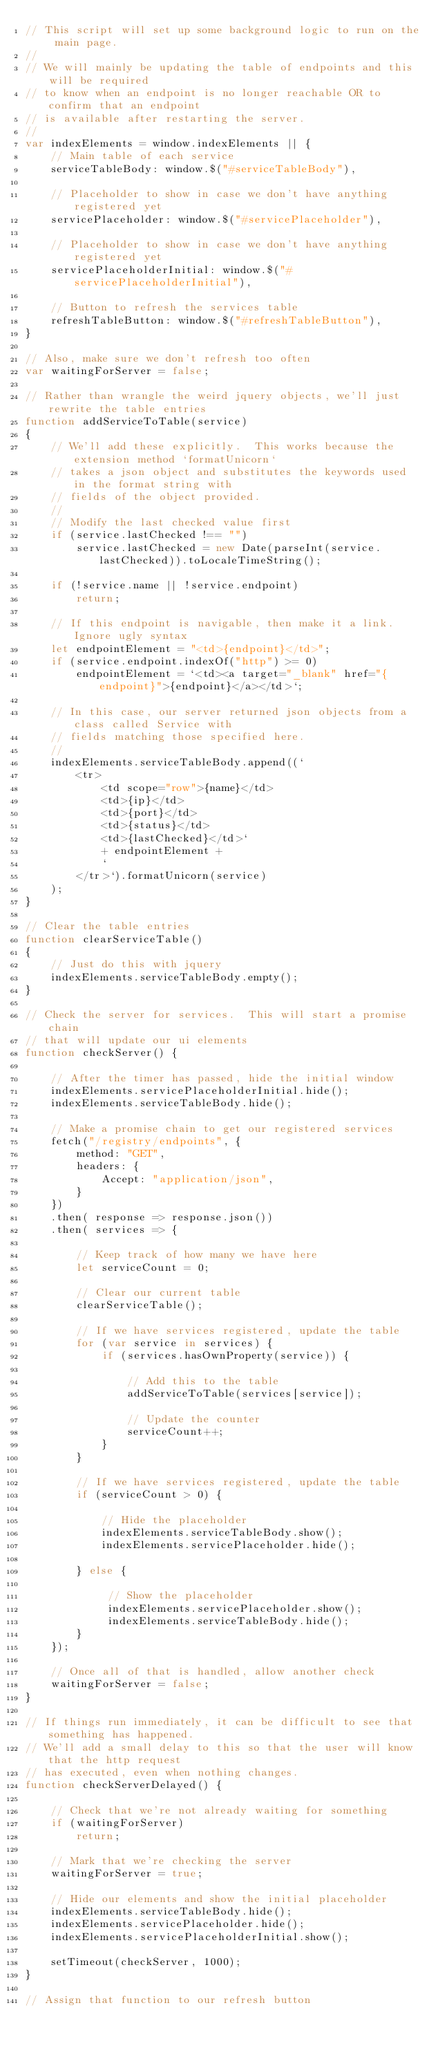<code> <loc_0><loc_0><loc_500><loc_500><_JavaScript_>// This script will set up some background logic to run on the main page.
//
// We will mainly be updating the table of endpoints and this will be required
// to know when an endpoint is no longer reachable OR to confirm that an endpoint
// is available after restarting the server.
//
var indexElements = window.indexElements || {
    // Main table of each service
    serviceTableBody: window.$("#serviceTableBody"),

    // Placeholder to show in case we don't have anything registered yet
    servicePlaceholder: window.$("#servicePlaceholder"),

    // Placeholder to show in case we don't have anything registered yet
    servicePlaceholderInitial: window.$("#servicePlaceholderInitial"),

    // Button to refresh the services table
    refreshTableButton: window.$("#refreshTableButton"),
}

// Also, make sure we don't refresh too often
var waitingForServer = false;

// Rather than wrangle the weird jquery objects, we'll just rewrite the table entries 
function addServiceToTable(service)
{
    // We'll add these explicitly.  This works because the extension method `formatUnicorn`
    // takes a json object and substitutes the keywords used in the format string with 
    // fields of the object provided.  
    //
    // Modify the last checked value first
    if (service.lastChecked !== "")
        service.lastChecked = new Date(parseInt(service.lastChecked)).toLocaleTimeString();

    if (!service.name || !service.endpoint)
        return;

    // If this endpoint is navigable, then make it a link.  Ignore ugly syntax
    let endpointElement = "<td>{endpoint}</td>";
    if (service.endpoint.indexOf("http") >= 0) 
        endpointElement = `<td><a target="_blank" href="{endpoint}">{endpoint}</a></td>`;

    // In this case, our server returned json objects from a class called Service with 
    // fields matching those specified here. 
    // 
    indexElements.serviceTableBody.append((`
        <tr>
            <td scope="row">{name}</td>
            <td>{ip}</td>
            <td>{port}</td>
            <td>{status}</td>
            <td>{lastChecked}</td>`
            + endpointElement +
            `
        </tr>`).formatUnicorn(service)
    );
}

// Clear the table entries
function clearServiceTable()
{
    // Just do this with jquery
    indexElements.serviceTableBody.empty();
}

// Check the server for services.  This will start a promise chain
// that will update our ui elements
function checkServer() {

    // After the timer has passed, hide the initial window
    indexElements.servicePlaceholderInitial.hide();
    indexElements.serviceTableBody.hide();

    // Make a promise chain to get our registered services
    fetch("/registry/endpoints", {
        method: "GET",
        headers: {
            Accept: "application/json",
        }
    })
    .then( response => response.json())
    .then( services => {

        // Keep track of how many we have here
        let serviceCount = 0;

        // Clear our current table
        clearServiceTable();

        // If we have services registered, update the table
        for (var service in services) {
            if (services.hasOwnProperty(service)) {

                // Add this to the table
                addServiceToTable(services[service]);

                // Update the counter
                serviceCount++;
            }
        }

        // If we have services registered, update the table
        if (serviceCount > 0) {
            
            // Hide the placeholder
            indexElements.serviceTableBody.show();
            indexElements.servicePlaceholder.hide();

        } else {

             // Show the placeholder
             indexElements.servicePlaceholder.show();
             indexElements.serviceTableBody.hide();
        }
    });

    // Once all of that is handled, allow another check
    waitingForServer = false;
}

// If things run immediately, it can be difficult to see that something has happened.
// We'll add a small delay to this so that the user will know that the http request
// has executed, even when nothing changes.
function checkServerDelayed() {

    // Check that we're not already waiting for something
    if (waitingForServer)
        return;
    
    // Mark that we're checking the server
    waitingForServer = true;

    // Hide our elements and show the initial placeholder
    indexElements.serviceTableBody.hide();
    indexElements.servicePlaceholder.hide();
    indexElements.servicePlaceholderInitial.show();

    setTimeout(checkServer, 1000);
}

// Assign that function to our refresh button</code> 